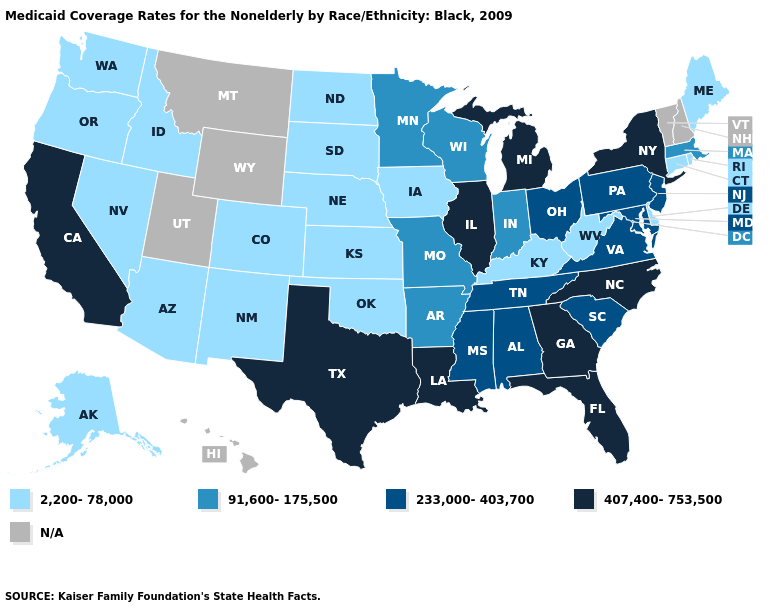Name the states that have a value in the range N/A?
Keep it brief. Hawaii, Montana, New Hampshire, Utah, Vermont, Wyoming. What is the lowest value in the USA?
Short answer required. 2,200-78,000. Which states have the highest value in the USA?
Quick response, please. California, Florida, Georgia, Illinois, Louisiana, Michigan, New York, North Carolina, Texas. What is the value of New Jersey?
Give a very brief answer. 233,000-403,700. Name the states that have a value in the range 233,000-403,700?
Keep it brief. Alabama, Maryland, Mississippi, New Jersey, Ohio, Pennsylvania, South Carolina, Tennessee, Virginia. What is the lowest value in the West?
Quick response, please. 2,200-78,000. Name the states that have a value in the range 2,200-78,000?
Keep it brief. Alaska, Arizona, Colorado, Connecticut, Delaware, Idaho, Iowa, Kansas, Kentucky, Maine, Nebraska, Nevada, New Mexico, North Dakota, Oklahoma, Oregon, Rhode Island, South Dakota, Washington, West Virginia. What is the value of Nevada?
Write a very short answer. 2,200-78,000. Does Illinois have the highest value in the USA?
Short answer required. Yes. Among the states that border Wisconsin , which have the highest value?
Answer briefly. Illinois, Michigan. Among the states that border Arkansas , does Mississippi have the highest value?
Quick response, please. No. Does the map have missing data?
Be succinct. Yes. What is the value of Louisiana?
Quick response, please. 407,400-753,500. 